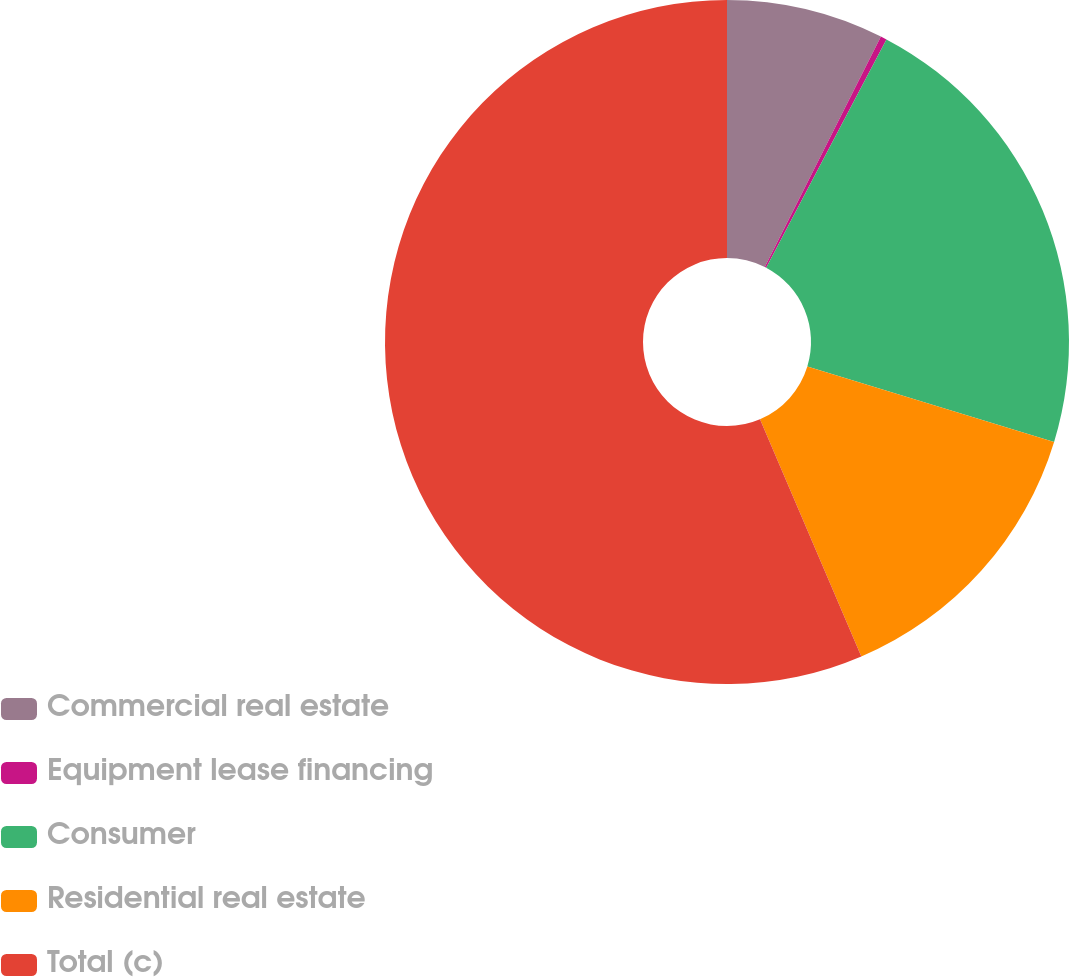Convert chart to OTSL. <chart><loc_0><loc_0><loc_500><loc_500><pie_chart><fcel>Commercial real estate<fcel>Equipment lease financing<fcel>Consumer<fcel>Residential real estate<fcel>Total (c)<nl><fcel>7.43%<fcel>0.29%<fcel>22.0%<fcel>13.86%<fcel>56.43%<nl></chart> 